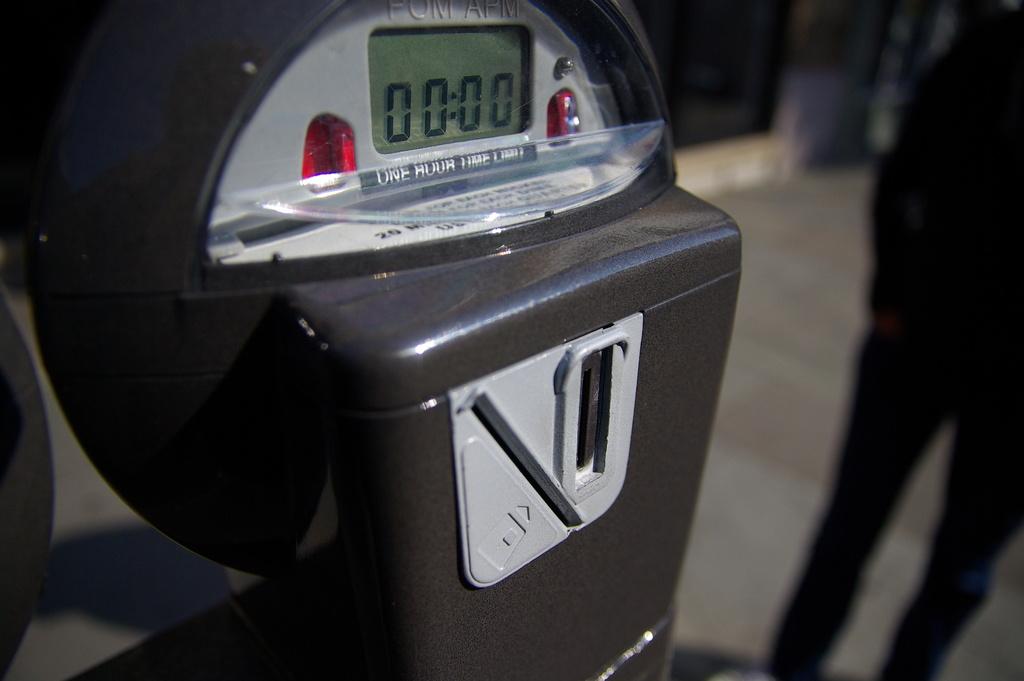Is the meter expired?
Make the answer very short. Yes. What is the time limit on the meter?
Keep it short and to the point. One hour. 